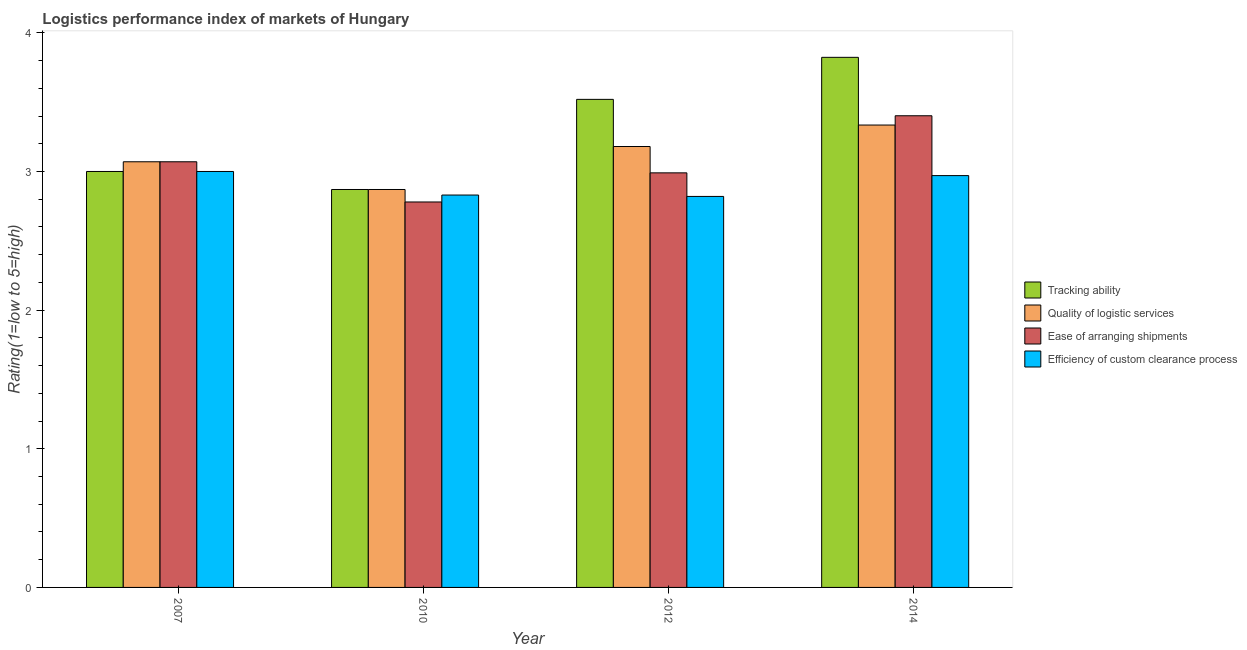Are the number of bars per tick equal to the number of legend labels?
Your answer should be compact. Yes. How many bars are there on the 4th tick from the left?
Your answer should be very brief. 4. What is the lpi rating of efficiency of custom clearance process in 2012?
Ensure brevity in your answer.  2.82. Across all years, what is the minimum lpi rating of tracking ability?
Give a very brief answer. 2.87. In which year was the lpi rating of efficiency of custom clearance process maximum?
Provide a short and direct response. 2007. In which year was the lpi rating of efficiency of custom clearance process minimum?
Provide a succinct answer. 2012. What is the total lpi rating of ease of arranging shipments in the graph?
Offer a terse response. 12.24. What is the difference between the lpi rating of efficiency of custom clearance process in 2007 and that in 2014?
Provide a succinct answer. 0.03. What is the difference between the lpi rating of tracking ability in 2014 and the lpi rating of ease of arranging shipments in 2012?
Give a very brief answer. 0.3. What is the average lpi rating of ease of arranging shipments per year?
Keep it short and to the point. 3.06. In the year 2012, what is the difference between the lpi rating of tracking ability and lpi rating of quality of logistic services?
Offer a terse response. 0. What is the ratio of the lpi rating of efficiency of custom clearance process in 2010 to that in 2014?
Your response must be concise. 0.95. What is the difference between the highest and the second highest lpi rating of quality of logistic services?
Keep it short and to the point. 0.15. What is the difference between the highest and the lowest lpi rating of tracking ability?
Offer a very short reply. 0.95. What does the 4th bar from the left in 2014 represents?
Provide a succinct answer. Efficiency of custom clearance process. What does the 1st bar from the right in 2014 represents?
Your answer should be compact. Efficiency of custom clearance process. Is it the case that in every year, the sum of the lpi rating of tracking ability and lpi rating of quality of logistic services is greater than the lpi rating of ease of arranging shipments?
Your answer should be very brief. Yes. How many bars are there?
Provide a short and direct response. 16. Are all the bars in the graph horizontal?
Ensure brevity in your answer.  No. Are the values on the major ticks of Y-axis written in scientific E-notation?
Offer a terse response. No. Does the graph contain any zero values?
Your response must be concise. No. Does the graph contain grids?
Your response must be concise. No. How many legend labels are there?
Offer a terse response. 4. What is the title of the graph?
Provide a short and direct response. Logistics performance index of markets of Hungary. What is the label or title of the X-axis?
Keep it short and to the point. Year. What is the label or title of the Y-axis?
Keep it short and to the point. Rating(1=low to 5=high). What is the Rating(1=low to 5=high) in Tracking ability in 2007?
Provide a short and direct response. 3. What is the Rating(1=low to 5=high) in Quality of logistic services in 2007?
Make the answer very short. 3.07. What is the Rating(1=low to 5=high) in Ease of arranging shipments in 2007?
Make the answer very short. 3.07. What is the Rating(1=low to 5=high) of Tracking ability in 2010?
Give a very brief answer. 2.87. What is the Rating(1=low to 5=high) in Quality of logistic services in 2010?
Your response must be concise. 2.87. What is the Rating(1=low to 5=high) in Ease of arranging shipments in 2010?
Offer a very short reply. 2.78. What is the Rating(1=low to 5=high) of Efficiency of custom clearance process in 2010?
Keep it short and to the point. 2.83. What is the Rating(1=low to 5=high) of Tracking ability in 2012?
Offer a very short reply. 3.52. What is the Rating(1=low to 5=high) of Quality of logistic services in 2012?
Ensure brevity in your answer.  3.18. What is the Rating(1=low to 5=high) of Ease of arranging shipments in 2012?
Your answer should be very brief. 2.99. What is the Rating(1=low to 5=high) in Efficiency of custom clearance process in 2012?
Offer a terse response. 2.82. What is the Rating(1=low to 5=high) of Tracking ability in 2014?
Keep it short and to the point. 3.82. What is the Rating(1=low to 5=high) in Quality of logistic services in 2014?
Offer a very short reply. 3.33. What is the Rating(1=low to 5=high) in Ease of arranging shipments in 2014?
Give a very brief answer. 3.4. What is the Rating(1=low to 5=high) in Efficiency of custom clearance process in 2014?
Keep it short and to the point. 2.97. Across all years, what is the maximum Rating(1=low to 5=high) of Tracking ability?
Your answer should be very brief. 3.82. Across all years, what is the maximum Rating(1=low to 5=high) of Quality of logistic services?
Your response must be concise. 3.33. Across all years, what is the maximum Rating(1=low to 5=high) in Ease of arranging shipments?
Ensure brevity in your answer.  3.4. Across all years, what is the minimum Rating(1=low to 5=high) in Tracking ability?
Offer a terse response. 2.87. Across all years, what is the minimum Rating(1=low to 5=high) in Quality of logistic services?
Provide a short and direct response. 2.87. Across all years, what is the minimum Rating(1=low to 5=high) of Ease of arranging shipments?
Make the answer very short. 2.78. Across all years, what is the minimum Rating(1=low to 5=high) in Efficiency of custom clearance process?
Provide a succinct answer. 2.82. What is the total Rating(1=low to 5=high) of Tracking ability in the graph?
Offer a very short reply. 13.21. What is the total Rating(1=low to 5=high) of Quality of logistic services in the graph?
Provide a succinct answer. 12.45. What is the total Rating(1=low to 5=high) in Ease of arranging shipments in the graph?
Provide a succinct answer. 12.24. What is the total Rating(1=low to 5=high) in Efficiency of custom clearance process in the graph?
Make the answer very short. 11.62. What is the difference between the Rating(1=low to 5=high) of Tracking ability in 2007 and that in 2010?
Offer a very short reply. 0.13. What is the difference between the Rating(1=low to 5=high) of Ease of arranging shipments in 2007 and that in 2010?
Give a very brief answer. 0.29. What is the difference between the Rating(1=low to 5=high) in Efficiency of custom clearance process in 2007 and that in 2010?
Provide a succinct answer. 0.17. What is the difference between the Rating(1=low to 5=high) of Tracking ability in 2007 and that in 2012?
Keep it short and to the point. -0.52. What is the difference between the Rating(1=low to 5=high) in Quality of logistic services in 2007 and that in 2012?
Make the answer very short. -0.11. What is the difference between the Rating(1=low to 5=high) in Efficiency of custom clearance process in 2007 and that in 2012?
Give a very brief answer. 0.18. What is the difference between the Rating(1=low to 5=high) in Tracking ability in 2007 and that in 2014?
Offer a terse response. -0.82. What is the difference between the Rating(1=low to 5=high) in Quality of logistic services in 2007 and that in 2014?
Give a very brief answer. -0.26. What is the difference between the Rating(1=low to 5=high) in Ease of arranging shipments in 2007 and that in 2014?
Keep it short and to the point. -0.33. What is the difference between the Rating(1=low to 5=high) of Efficiency of custom clearance process in 2007 and that in 2014?
Offer a terse response. 0.03. What is the difference between the Rating(1=low to 5=high) in Tracking ability in 2010 and that in 2012?
Make the answer very short. -0.65. What is the difference between the Rating(1=low to 5=high) of Quality of logistic services in 2010 and that in 2012?
Ensure brevity in your answer.  -0.31. What is the difference between the Rating(1=low to 5=high) in Ease of arranging shipments in 2010 and that in 2012?
Your response must be concise. -0.21. What is the difference between the Rating(1=low to 5=high) in Tracking ability in 2010 and that in 2014?
Your response must be concise. -0.95. What is the difference between the Rating(1=low to 5=high) of Quality of logistic services in 2010 and that in 2014?
Keep it short and to the point. -0.46. What is the difference between the Rating(1=low to 5=high) in Ease of arranging shipments in 2010 and that in 2014?
Offer a very short reply. -0.62. What is the difference between the Rating(1=low to 5=high) in Efficiency of custom clearance process in 2010 and that in 2014?
Your answer should be compact. -0.14. What is the difference between the Rating(1=low to 5=high) in Tracking ability in 2012 and that in 2014?
Provide a short and direct response. -0.3. What is the difference between the Rating(1=low to 5=high) of Quality of logistic services in 2012 and that in 2014?
Your answer should be very brief. -0.15. What is the difference between the Rating(1=low to 5=high) in Ease of arranging shipments in 2012 and that in 2014?
Provide a short and direct response. -0.41. What is the difference between the Rating(1=low to 5=high) of Efficiency of custom clearance process in 2012 and that in 2014?
Give a very brief answer. -0.15. What is the difference between the Rating(1=low to 5=high) of Tracking ability in 2007 and the Rating(1=low to 5=high) of Quality of logistic services in 2010?
Your answer should be very brief. 0.13. What is the difference between the Rating(1=low to 5=high) in Tracking ability in 2007 and the Rating(1=low to 5=high) in Ease of arranging shipments in 2010?
Provide a short and direct response. 0.22. What is the difference between the Rating(1=low to 5=high) of Tracking ability in 2007 and the Rating(1=low to 5=high) of Efficiency of custom clearance process in 2010?
Ensure brevity in your answer.  0.17. What is the difference between the Rating(1=low to 5=high) in Quality of logistic services in 2007 and the Rating(1=low to 5=high) in Ease of arranging shipments in 2010?
Your answer should be very brief. 0.29. What is the difference between the Rating(1=low to 5=high) in Quality of logistic services in 2007 and the Rating(1=low to 5=high) in Efficiency of custom clearance process in 2010?
Your response must be concise. 0.24. What is the difference between the Rating(1=low to 5=high) in Ease of arranging shipments in 2007 and the Rating(1=low to 5=high) in Efficiency of custom clearance process in 2010?
Your answer should be compact. 0.24. What is the difference between the Rating(1=low to 5=high) of Tracking ability in 2007 and the Rating(1=low to 5=high) of Quality of logistic services in 2012?
Offer a terse response. -0.18. What is the difference between the Rating(1=low to 5=high) in Tracking ability in 2007 and the Rating(1=low to 5=high) in Efficiency of custom clearance process in 2012?
Provide a succinct answer. 0.18. What is the difference between the Rating(1=low to 5=high) in Quality of logistic services in 2007 and the Rating(1=low to 5=high) in Ease of arranging shipments in 2012?
Keep it short and to the point. 0.08. What is the difference between the Rating(1=low to 5=high) in Ease of arranging shipments in 2007 and the Rating(1=low to 5=high) in Efficiency of custom clearance process in 2012?
Ensure brevity in your answer.  0.25. What is the difference between the Rating(1=low to 5=high) in Tracking ability in 2007 and the Rating(1=low to 5=high) in Quality of logistic services in 2014?
Provide a short and direct response. -0.33. What is the difference between the Rating(1=low to 5=high) in Tracking ability in 2007 and the Rating(1=low to 5=high) in Ease of arranging shipments in 2014?
Ensure brevity in your answer.  -0.4. What is the difference between the Rating(1=low to 5=high) of Tracking ability in 2007 and the Rating(1=low to 5=high) of Efficiency of custom clearance process in 2014?
Offer a terse response. 0.03. What is the difference between the Rating(1=low to 5=high) in Quality of logistic services in 2007 and the Rating(1=low to 5=high) in Ease of arranging shipments in 2014?
Provide a short and direct response. -0.33. What is the difference between the Rating(1=low to 5=high) of Quality of logistic services in 2007 and the Rating(1=low to 5=high) of Efficiency of custom clearance process in 2014?
Provide a succinct answer. 0.1. What is the difference between the Rating(1=low to 5=high) in Ease of arranging shipments in 2007 and the Rating(1=low to 5=high) in Efficiency of custom clearance process in 2014?
Provide a short and direct response. 0.1. What is the difference between the Rating(1=low to 5=high) in Tracking ability in 2010 and the Rating(1=low to 5=high) in Quality of logistic services in 2012?
Provide a short and direct response. -0.31. What is the difference between the Rating(1=low to 5=high) of Tracking ability in 2010 and the Rating(1=low to 5=high) of Ease of arranging shipments in 2012?
Your response must be concise. -0.12. What is the difference between the Rating(1=low to 5=high) of Tracking ability in 2010 and the Rating(1=low to 5=high) of Efficiency of custom clearance process in 2012?
Your answer should be compact. 0.05. What is the difference between the Rating(1=low to 5=high) of Quality of logistic services in 2010 and the Rating(1=low to 5=high) of Ease of arranging shipments in 2012?
Provide a short and direct response. -0.12. What is the difference between the Rating(1=low to 5=high) in Quality of logistic services in 2010 and the Rating(1=low to 5=high) in Efficiency of custom clearance process in 2012?
Make the answer very short. 0.05. What is the difference between the Rating(1=low to 5=high) in Ease of arranging shipments in 2010 and the Rating(1=low to 5=high) in Efficiency of custom clearance process in 2012?
Provide a short and direct response. -0.04. What is the difference between the Rating(1=low to 5=high) in Tracking ability in 2010 and the Rating(1=low to 5=high) in Quality of logistic services in 2014?
Make the answer very short. -0.46. What is the difference between the Rating(1=low to 5=high) in Tracking ability in 2010 and the Rating(1=low to 5=high) in Ease of arranging shipments in 2014?
Your answer should be very brief. -0.53. What is the difference between the Rating(1=low to 5=high) of Tracking ability in 2010 and the Rating(1=low to 5=high) of Efficiency of custom clearance process in 2014?
Your answer should be compact. -0.1. What is the difference between the Rating(1=low to 5=high) in Quality of logistic services in 2010 and the Rating(1=low to 5=high) in Ease of arranging shipments in 2014?
Make the answer very short. -0.53. What is the difference between the Rating(1=low to 5=high) in Quality of logistic services in 2010 and the Rating(1=low to 5=high) in Efficiency of custom clearance process in 2014?
Your answer should be compact. -0.1. What is the difference between the Rating(1=low to 5=high) in Ease of arranging shipments in 2010 and the Rating(1=low to 5=high) in Efficiency of custom clearance process in 2014?
Offer a very short reply. -0.19. What is the difference between the Rating(1=low to 5=high) in Tracking ability in 2012 and the Rating(1=low to 5=high) in Quality of logistic services in 2014?
Your answer should be compact. 0.19. What is the difference between the Rating(1=low to 5=high) in Tracking ability in 2012 and the Rating(1=low to 5=high) in Ease of arranging shipments in 2014?
Your answer should be very brief. 0.12. What is the difference between the Rating(1=low to 5=high) of Tracking ability in 2012 and the Rating(1=low to 5=high) of Efficiency of custom clearance process in 2014?
Offer a terse response. 0.55. What is the difference between the Rating(1=low to 5=high) in Quality of logistic services in 2012 and the Rating(1=low to 5=high) in Ease of arranging shipments in 2014?
Offer a terse response. -0.22. What is the difference between the Rating(1=low to 5=high) of Quality of logistic services in 2012 and the Rating(1=low to 5=high) of Efficiency of custom clearance process in 2014?
Give a very brief answer. 0.21. What is the difference between the Rating(1=low to 5=high) in Ease of arranging shipments in 2012 and the Rating(1=low to 5=high) in Efficiency of custom clearance process in 2014?
Ensure brevity in your answer.  0.02. What is the average Rating(1=low to 5=high) in Tracking ability per year?
Your answer should be compact. 3.3. What is the average Rating(1=low to 5=high) in Quality of logistic services per year?
Offer a terse response. 3.11. What is the average Rating(1=low to 5=high) in Ease of arranging shipments per year?
Give a very brief answer. 3.06. What is the average Rating(1=low to 5=high) in Efficiency of custom clearance process per year?
Your answer should be very brief. 2.91. In the year 2007, what is the difference between the Rating(1=low to 5=high) of Tracking ability and Rating(1=low to 5=high) of Quality of logistic services?
Your answer should be compact. -0.07. In the year 2007, what is the difference between the Rating(1=low to 5=high) in Tracking ability and Rating(1=low to 5=high) in Ease of arranging shipments?
Offer a terse response. -0.07. In the year 2007, what is the difference between the Rating(1=low to 5=high) in Quality of logistic services and Rating(1=low to 5=high) in Ease of arranging shipments?
Offer a terse response. 0. In the year 2007, what is the difference between the Rating(1=low to 5=high) in Quality of logistic services and Rating(1=low to 5=high) in Efficiency of custom clearance process?
Provide a succinct answer. 0.07. In the year 2007, what is the difference between the Rating(1=low to 5=high) of Ease of arranging shipments and Rating(1=low to 5=high) of Efficiency of custom clearance process?
Your response must be concise. 0.07. In the year 2010, what is the difference between the Rating(1=low to 5=high) of Tracking ability and Rating(1=low to 5=high) of Quality of logistic services?
Offer a terse response. 0. In the year 2010, what is the difference between the Rating(1=low to 5=high) of Tracking ability and Rating(1=low to 5=high) of Ease of arranging shipments?
Your answer should be compact. 0.09. In the year 2010, what is the difference between the Rating(1=low to 5=high) in Tracking ability and Rating(1=low to 5=high) in Efficiency of custom clearance process?
Provide a short and direct response. 0.04. In the year 2010, what is the difference between the Rating(1=low to 5=high) of Quality of logistic services and Rating(1=low to 5=high) of Ease of arranging shipments?
Provide a succinct answer. 0.09. In the year 2010, what is the difference between the Rating(1=low to 5=high) in Quality of logistic services and Rating(1=low to 5=high) in Efficiency of custom clearance process?
Offer a very short reply. 0.04. In the year 2012, what is the difference between the Rating(1=low to 5=high) of Tracking ability and Rating(1=low to 5=high) of Quality of logistic services?
Give a very brief answer. 0.34. In the year 2012, what is the difference between the Rating(1=low to 5=high) of Tracking ability and Rating(1=low to 5=high) of Ease of arranging shipments?
Give a very brief answer. 0.53. In the year 2012, what is the difference between the Rating(1=low to 5=high) in Quality of logistic services and Rating(1=low to 5=high) in Ease of arranging shipments?
Offer a very short reply. 0.19. In the year 2012, what is the difference between the Rating(1=low to 5=high) in Quality of logistic services and Rating(1=low to 5=high) in Efficiency of custom clearance process?
Your answer should be compact. 0.36. In the year 2012, what is the difference between the Rating(1=low to 5=high) of Ease of arranging shipments and Rating(1=low to 5=high) of Efficiency of custom clearance process?
Your answer should be compact. 0.17. In the year 2014, what is the difference between the Rating(1=low to 5=high) of Tracking ability and Rating(1=low to 5=high) of Quality of logistic services?
Offer a terse response. 0.49. In the year 2014, what is the difference between the Rating(1=low to 5=high) in Tracking ability and Rating(1=low to 5=high) in Ease of arranging shipments?
Ensure brevity in your answer.  0.42. In the year 2014, what is the difference between the Rating(1=low to 5=high) in Tracking ability and Rating(1=low to 5=high) in Efficiency of custom clearance process?
Keep it short and to the point. 0.85. In the year 2014, what is the difference between the Rating(1=low to 5=high) of Quality of logistic services and Rating(1=low to 5=high) of Ease of arranging shipments?
Give a very brief answer. -0.07. In the year 2014, what is the difference between the Rating(1=low to 5=high) in Quality of logistic services and Rating(1=low to 5=high) in Efficiency of custom clearance process?
Offer a very short reply. 0.36. In the year 2014, what is the difference between the Rating(1=low to 5=high) in Ease of arranging shipments and Rating(1=low to 5=high) in Efficiency of custom clearance process?
Provide a short and direct response. 0.43. What is the ratio of the Rating(1=low to 5=high) of Tracking ability in 2007 to that in 2010?
Offer a terse response. 1.05. What is the ratio of the Rating(1=low to 5=high) of Quality of logistic services in 2007 to that in 2010?
Your answer should be very brief. 1.07. What is the ratio of the Rating(1=low to 5=high) in Ease of arranging shipments in 2007 to that in 2010?
Offer a terse response. 1.1. What is the ratio of the Rating(1=low to 5=high) in Efficiency of custom clearance process in 2007 to that in 2010?
Keep it short and to the point. 1.06. What is the ratio of the Rating(1=low to 5=high) of Tracking ability in 2007 to that in 2012?
Your answer should be very brief. 0.85. What is the ratio of the Rating(1=low to 5=high) of Quality of logistic services in 2007 to that in 2012?
Provide a succinct answer. 0.97. What is the ratio of the Rating(1=low to 5=high) of Ease of arranging shipments in 2007 to that in 2012?
Ensure brevity in your answer.  1.03. What is the ratio of the Rating(1=low to 5=high) in Efficiency of custom clearance process in 2007 to that in 2012?
Provide a short and direct response. 1.06. What is the ratio of the Rating(1=low to 5=high) of Tracking ability in 2007 to that in 2014?
Ensure brevity in your answer.  0.78. What is the ratio of the Rating(1=low to 5=high) of Quality of logistic services in 2007 to that in 2014?
Ensure brevity in your answer.  0.92. What is the ratio of the Rating(1=low to 5=high) of Ease of arranging shipments in 2007 to that in 2014?
Provide a short and direct response. 0.9. What is the ratio of the Rating(1=low to 5=high) in Tracking ability in 2010 to that in 2012?
Offer a very short reply. 0.82. What is the ratio of the Rating(1=low to 5=high) of Quality of logistic services in 2010 to that in 2012?
Offer a terse response. 0.9. What is the ratio of the Rating(1=low to 5=high) in Ease of arranging shipments in 2010 to that in 2012?
Provide a succinct answer. 0.93. What is the ratio of the Rating(1=low to 5=high) of Efficiency of custom clearance process in 2010 to that in 2012?
Give a very brief answer. 1. What is the ratio of the Rating(1=low to 5=high) of Tracking ability in 2010 to that in 2014?
Ensure brevity in your answer.  0.75. What is the ratio of the Rating(1=low to 5=high) of Quality of logistic services in 2010 to that in 2014?
Your answer should be compact. 0.86. What is the ratio of the Rating(1=low to 5=high) in Ease of arranging shipments in 2010 to that in 2014?
Ensure brevity in your answer.  0.82. What is the ratio of the Rating(1=low to 5=high) of Efficiency of custom clearance process in 2010 to that in 2014?
Your answer should be very brief. 0.95. What is the ratio of the Rating(1=low to 5=high) in Tracking ability in 2012 to that in 2014?
Ensure brevity in your answer.  0.92. What is the ratio of the Rating(1=low to 5=high) in Quality of logistic services in 2012 to that in 2014?
Your answer should be very brief. 0.95. What is the ratio of the Rating(1=low to 5=high) of Ease of arranging shipments in 2012 to that in 2014?
Ensure brevity in your answer.  0.88. What is the ratio of the Rating(1=low to 5=high) in Efficiency of custom clearance process in 2012 to that in 2014?
Your answer should be very brief. 0.95. What is the difference between the highest and the second highest Rating(1=low to 5=high) in Tracking ability?
Your answer should be very brief. 0.3. What is the difference between the highest and the second highest Rating(1=low to 5=high) of Quality of logistic services?
Ensure brevity in your answer.  0.15. What is the difference between the highest and the second highest Rating(1=low to 5=high) in Ease of arranging shipments?
Make the answer very short. 0.33. What is the difference between the highest and the second highest Rating(1=low to 5=high) of Efficiency of custom clearance process?
Give a very brief answer. 0.03. What is the difference between the highest and the lowest Rating(1=low to 5=high) in Tracking ability?
Provide a succinct answer. 0.95. What is the difference between the highest and the lowest Rating(1=low to 5=high) in Quality of logistic services?
Offer a terse response. 0.46. What is the difference between the highest and the lowest Rating(1=low to 5=high) in Ease of arranging shipments?
Provide a succinct answer. 0.62. What is the difference between the highest and the lowest Rating(1=low to 5=high) of Efficiency of custom clearance process?
Give a very brief answer. 0.18. 